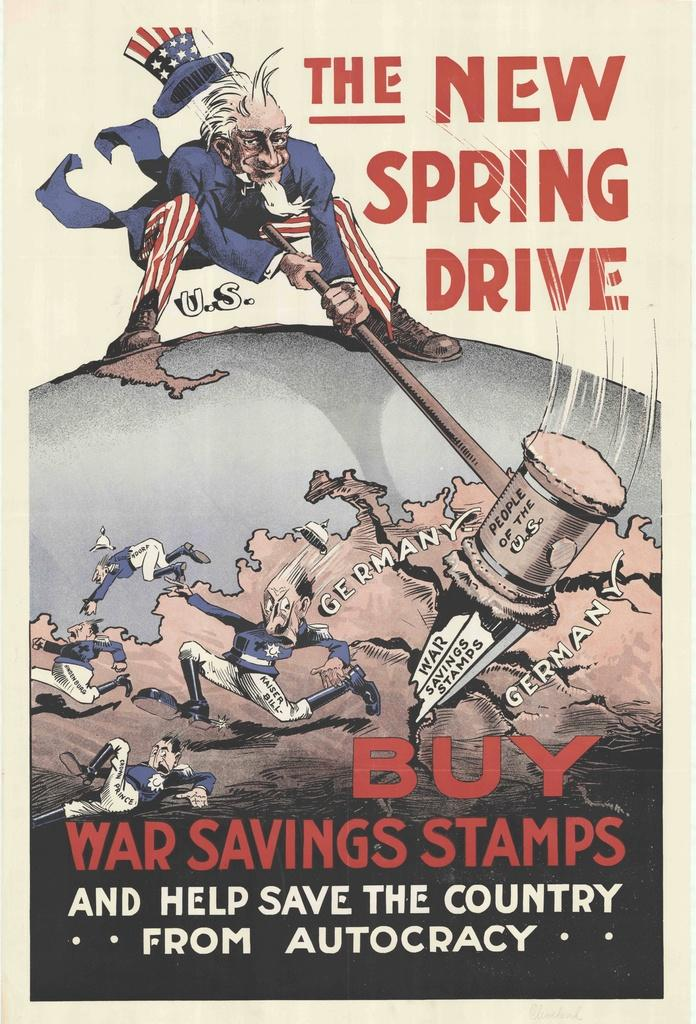Provide a one-sentence caption for the provided image. An old advertisement to buy war saving stamps to fund  war. 